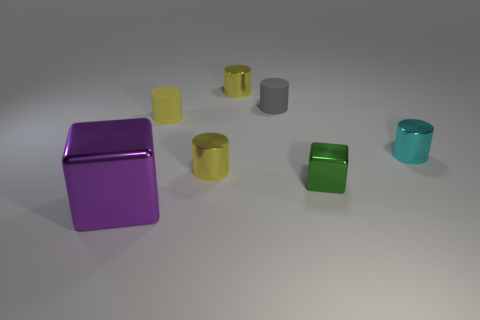Subtract all cyan cubes. How many yellow cylinders are left? 3 Subtract 1 cylinders. How many cylinders are left? 4 Add 2 purple shiny cubes. How many objects exist? 9 Subtract all gray cylinders. How many cylinders are left? 4 Subtract all small yellow matte cylinders. How many cylinders are left? 4 Subtract all green cylinders. Subtract all yellow balls. How many cylinders are left? 5 Subtract all cylinders. How many objects are left? 2 Subtract all cyan cylinders. Subtract all rubber objects. How many objects are left? 4 Add 6 tiny cyan things. How many tiny cyan things are left? 7 Add 5 big red metal cubes. How many big red metal cubes exist? 5 